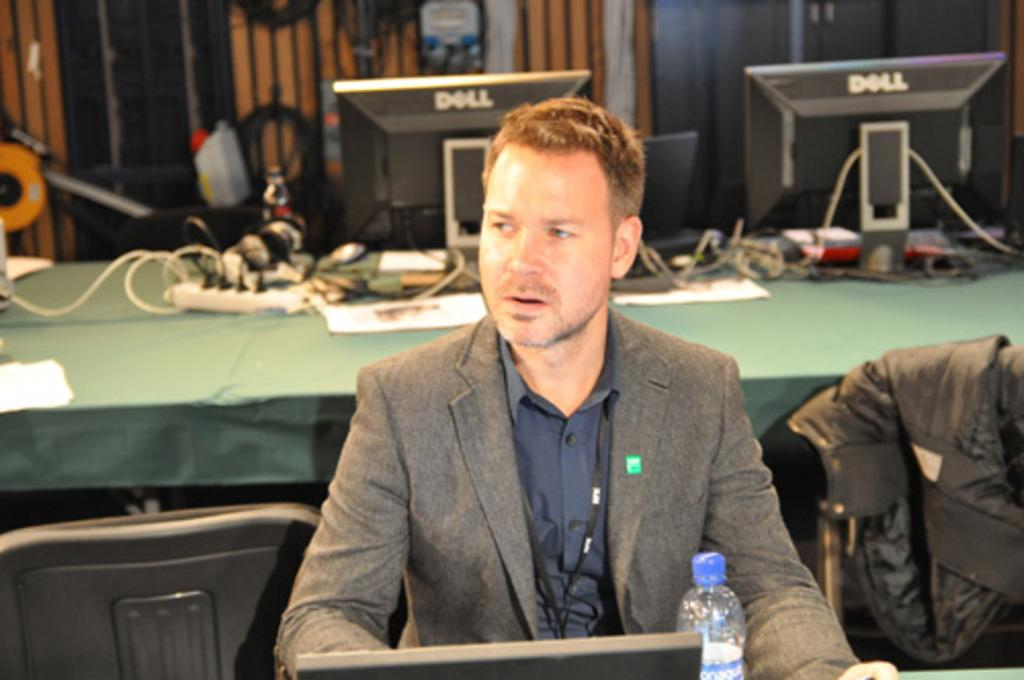Who is present in the image? There is a man in the image. What is the man wearing? The man is wearing a coat and a shirt. What can be seen in the background of the image? There are computer monitors on a table in the background. How much ink is required to fill the man's coat in the image? There is no ink involved in the man's coat in the image, as it is a physical garment and not a drawing or printed material. 